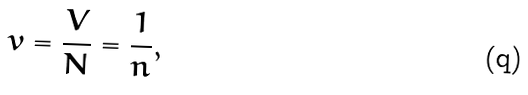<formula> <loc_0><loc_0><loc_500><loc_500>v = \frac { V } { N } = \frac { 1 } { n } ,</formula> 